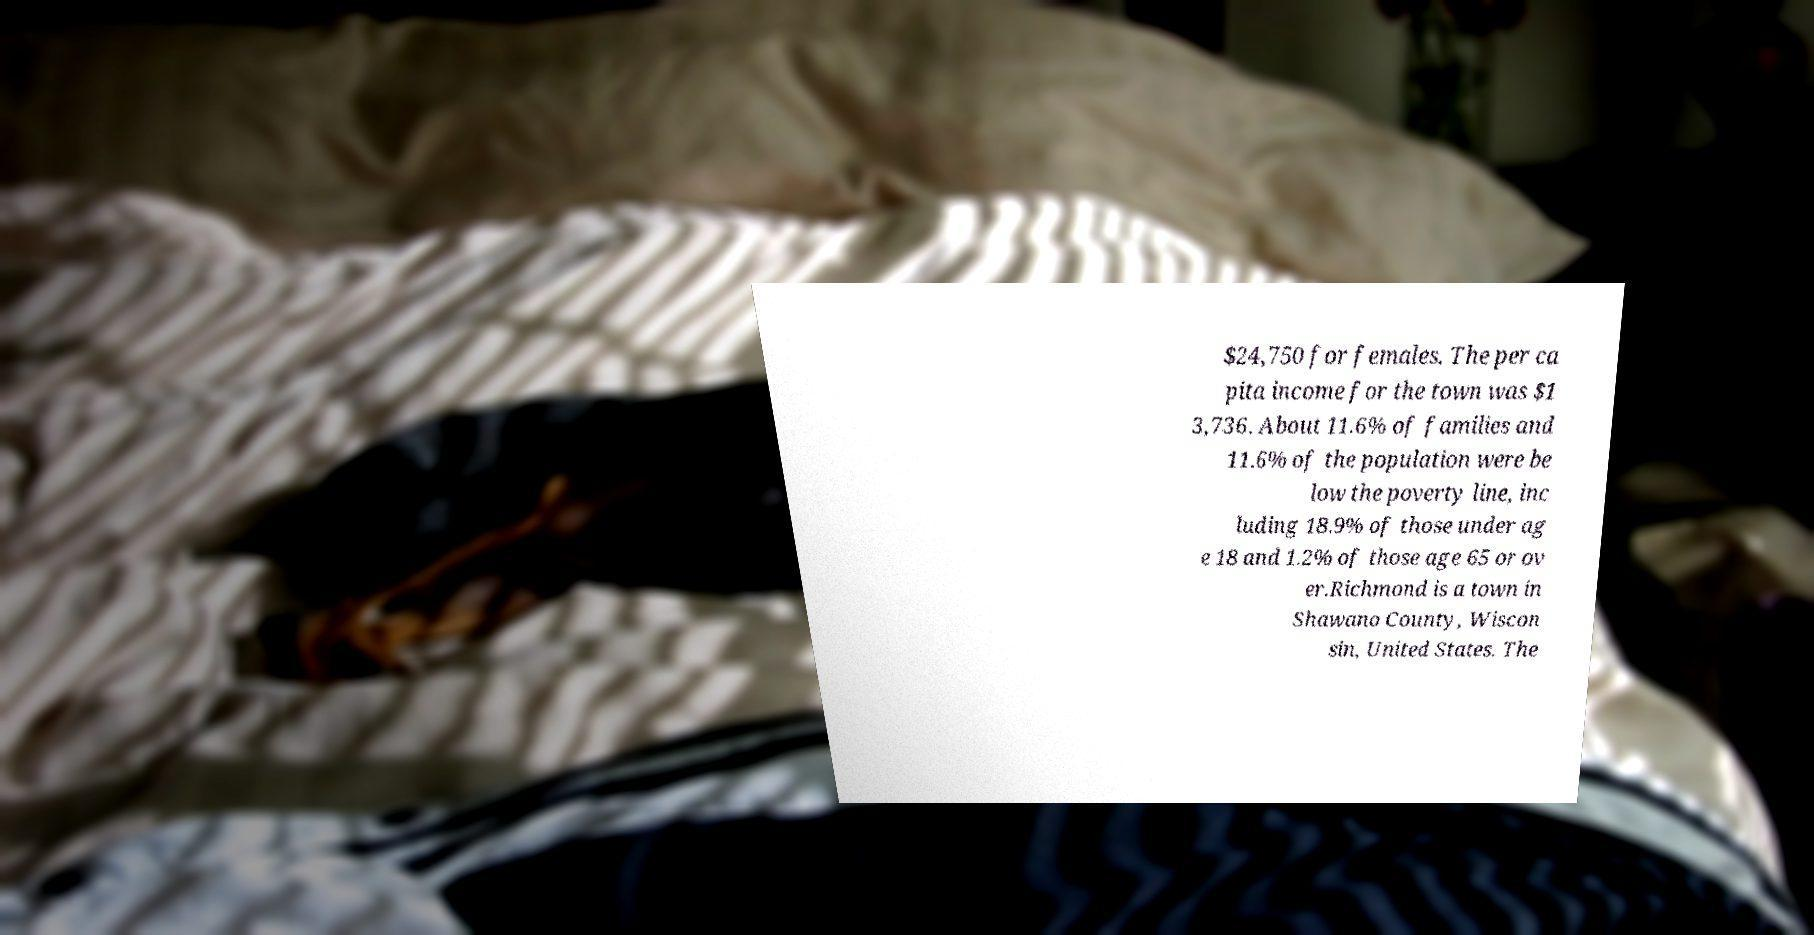Please read and relay the text visible in this image. What does it say? $24,750 for females. The per ca pita income for the town was $1 3,736. About 11.6% of families and 11.6% of the population were be low the poverty line, inc luding 18.9% of those under ag e 18 and 1.2% of those age 65 or ov er.Richmond is a town in Shawano County, Wiscon sin, United States. The 